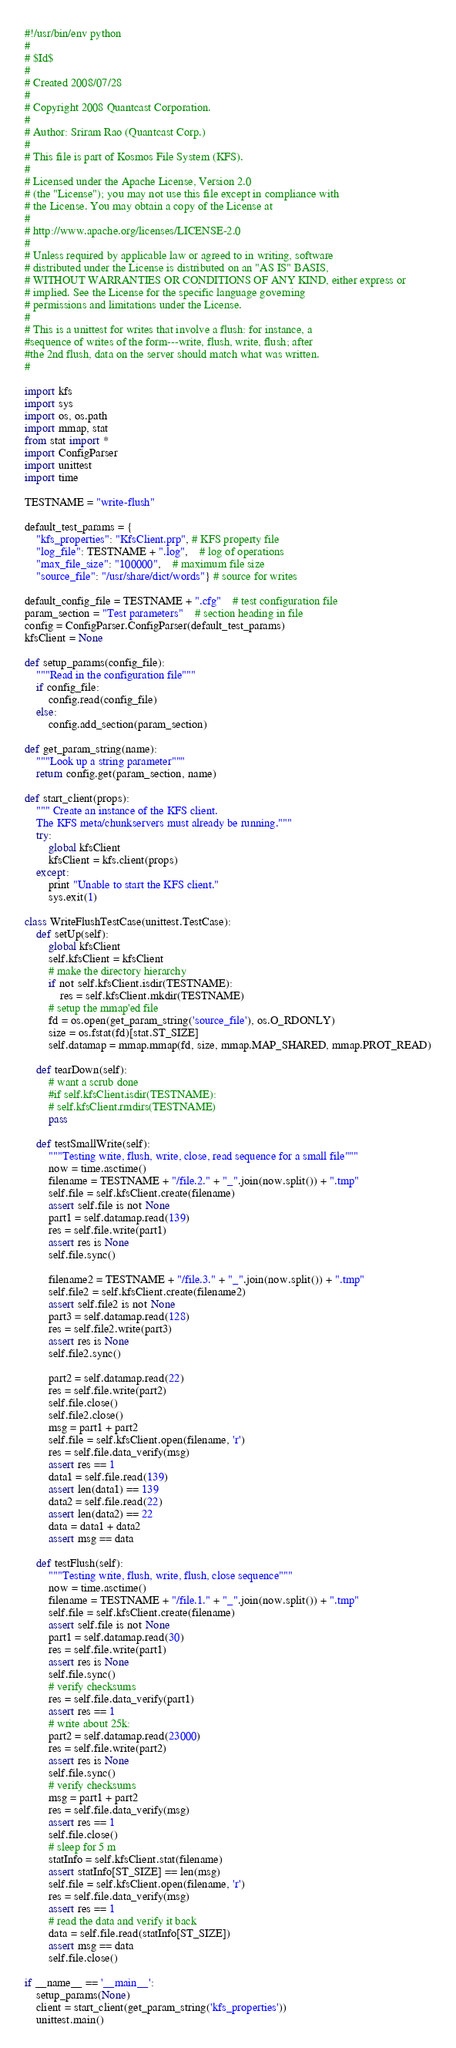Convert code to text. <code><loc_0><loc_0><loc_500><loc_500><_Python_>#!/usr/bin/env python
#
# $Id$
#
# Created 2008/07/28
#
# Copyright 2008 Quantcast Corporation.
#
# Author: Sriram Rao (Quantcast Corp.)
#
# This file is part of Kosmos File System (KFS).
#
# Licensed under the Apache License, Version 2.0
# (the "License"); you may not use this file except in compliance with
# the License. You may obtain a copy of the License at
#
# http://www.apache.org/licenses/LICENSE-2.0
#
# Unless required by applicable law or agreed to in writing, software
# distributed under the License is distributed on an "AS IS" BASIS,
# WITHOUT WARRANTIES OR CONDITIONS OF ANY KIND, either express or
# implied. See the License for the specific language governing
# permissions and limitations under the License.
#
# This is a unittest for writes that involve a flush: for instance, a
#sequence of writes of the form---write, flush, write, flush; after
#the 2nd flush, data on the server should match what was written.
#

import kfs
import sys
import os, os.path
import mmap, stat
from stat import *
import ConfigParser
import unittest
import time

TESTNAME = "write-flush"

default_test_params = {
	"kfs_properties": "KfsClient.prp", # KFS property file
	"log_file": TESTNAME + ".log",	# log of operations
	"max_file_size": "100000",	# maximum file size
	"source_file": "/usr/share/dict/words"} # source for writes

default_config_file = TESTNAME + ".cfg"	# test configuration file
param_section = "Test parameters"	# section heading in file
config = ConfigParser.ConfigParser(default_test_params)
kfsClient = None

def setup_params(config_file):
    """Read in the configuration file"""
    if config_file:
        config.read(config_file)
    else:
        config.add_section(param_section)

def get_param_string(name):
    """Look up a string parameter"""
    return config.get(param_section, name)

def start_client(props):
    """ Create an instance of the KFS client.
    The KFS meta/chunkservers must already be running."""
    try:
        global kfsClient
        kfsClient = kfs.client(props)
    except:
        print "Unable to start the KFS client."
        sys.exit(1)

class WriteFlushTestCase(unittest.TestCase):
    def setUp(self):
        global kfsClient
        self.kfsClient = kfsClient
        # make the directory hierarchy
        if not self.kfsClient.isdir(TESTNAME):
            res = self.kfsClient.mkdir(TESTNAME)
        # setup the mmap'ed file
        fd = os.open(get_param_string('source_file'), os.O_RDONLY)
        size = os.fstat(fd)[stat.ST_SIZE]
        self.datamap = mmap.mmap(fd, size, mmap.MAP_SHARED, mmap.PROT_READ)

    def tearDown(self):
        # want a scrub done
        #if self.kfsClient.isdir(TESTNAME):
        # self.kfsClient.rmdirs(TESTNAME)
        pass

    def testSmallWrite(self):
        """Testing write, flush, write, close, read sequence for a small file"""
        now = time.asctime()
        filename = TESTNAME + "/file.2." + "_".join(now.split()) + ".tmp"
        self.file = self.kfsClient.create(filename)
        assert self.file is not None
        part1 = self.datamap.read(139)
        res = self.file.write(part1)
        assert res is None
        self.file.sync()

        filename2 = TESTNAME + "/file.3." + "_".join(now.split()) + ".tmp"
        self.file2 = self.kfsClient.create(filename2)
        assert self.file2 is not None
        part3 = self.datamap.read(128)
        res = self.file2.write(part3)
        assert res is None
        self.file2.sync()
        
        part2 = self.datamap.read(22)
        res = self.file.write(part2)        
        self.file.close()
        self.file2.close()
        msg = part1 + part2
        self.file = self.kfsClient.open(filename, 'r')
        res = self.file.data_verify(msg)
        assert res == 1
        data1 = self.file.read(139)
        assert len(data1) == 139
        data2 = self.file.read(22)
        assert len(data2) == 22
        data = data1 + data2
        assert msg == data
        
    def testFlush(self):
        """Testing write, flush, write, flush, close sequence"""
        now = time.asctime()
        filename = TESTNAME + "/file.1." + "_".join(now.split()) + ".tmp"
        self.file = self.kfsClient.create(filename)
        assert self.file is not None
        part1 = self.datamap.read(30)
        res = self.file.write(part1)
        assert res is None
        self.file.sync()
        # verify checksums
        res = self.file.data_verify(part1)
        assert res == 1
        # write about 25k:
        part2 = self.datamap.read(23000)
        res = self.file.write(part2)
        assert res is None
        self.file.sync()
        # verify checksums
        msg = part1 + part2
        res = self.file.data_verify(msg)
        assert res == 1        
        self.file.close()
        # sleep for 5 m
        statInfo = self.kfsClient.stat(filename)
        assert statInfo[ST_SIZE] == len(msg)
        self.file = self.kfsClient.open(filename, 'r')
        res = self.file.data_verify(msg)
        assert res == 1
        # read the data and verify it back
        data = self.file.read(statInfo[ST_SIZE])
        assert msg == data
        self.file.close()

if __name__ == '__main__':
    setup_params(None)
    client = start_client(get_param_string('kfs_properties'))
    unittest.main()
</code> 